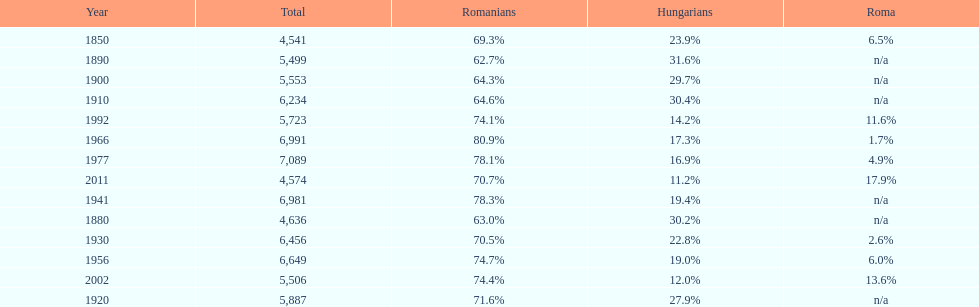What percent of the population were romanians according to the last year on this chart? 70.7%. Would you mind parsing the complete table? {'header': ['Year', 'Total', 'Romanians', 'Hungarians', 'Roma'], 'rows': [['1850', '4,541', '69.3%', '23.9%', '6.5%'], ['1890', '5,499', '62.7%', '31.6%', 'n/a'], ['1900', '5,553', '64.3%', '29.7%', 'n/a'], ['1910', '6,234', '64.6%', '30.4%', 'n/a'], ['1992', '5,723', '74.1%', '14.2%', '11.6%'], ['1966', '6,991', '80.9%', '17.3%', '1.7%'], ['1977', '7,089', '78.1%', '16.9%', '4.9%'], ['2011', '4,574', '70.7%', '11.2%', '17.9%'], ['1941', '6,981', '78.3%', '19.4%', 'n/a'], ['1880', '4,636', '63.0%', '30.2%', 'n/a'], ['1930', '6,456', '70.5%', '22.8%', '2.6%'], ['1956', '6,649', '74.7%', '19.0%', '6.0%'], ['2002', '5,506', '74.4%', '12.0%', '13.6%'], ['1920', '5,887', '71.6%', '27.9%', 'n/a']]} 